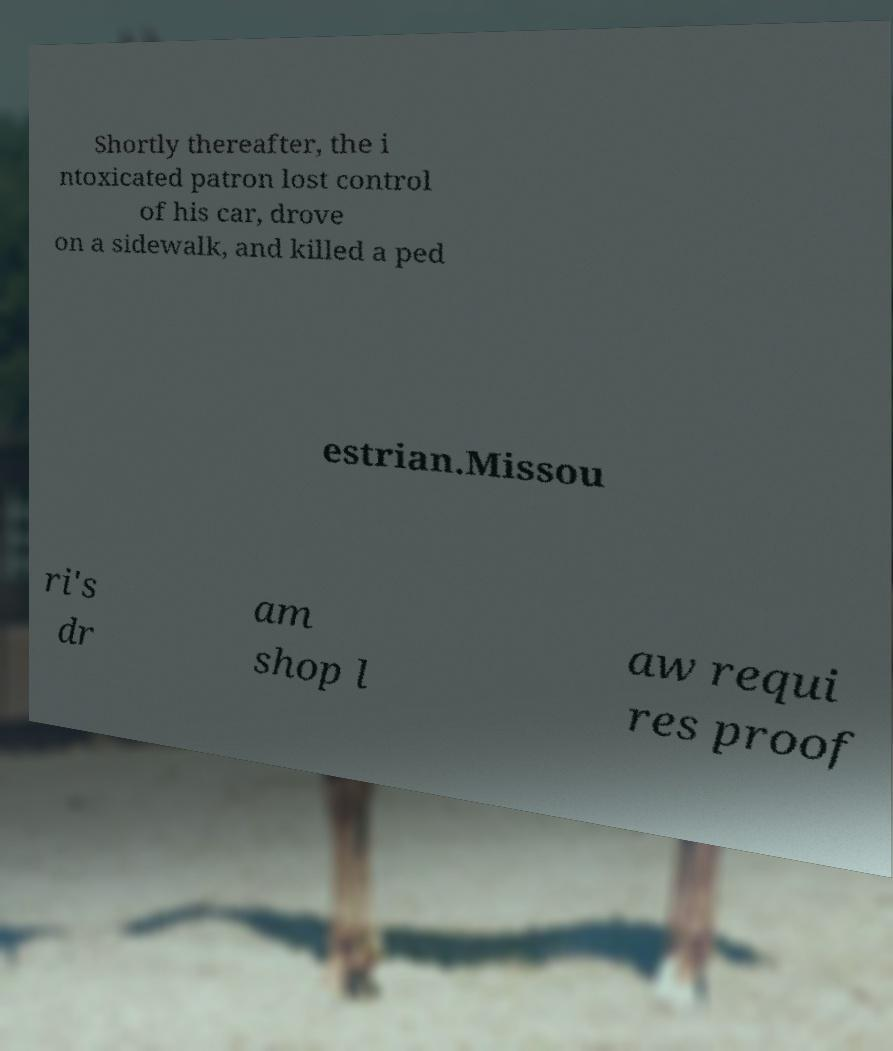Can you accurately transcribe the text from the provided image for me? Shortly thereafter, the i ntoxicated patron lost control of his car, drove on a sidewalk, and killed a ped estrian.Missou ri's dr am shop l aw requi res proof 